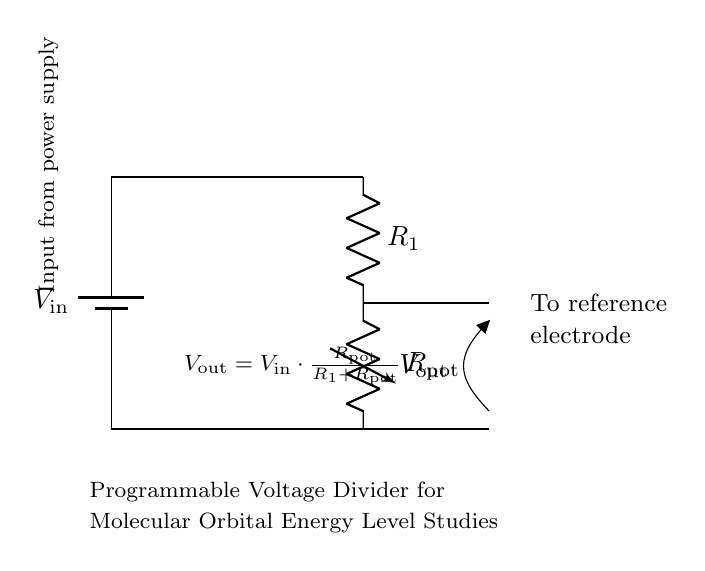What is the input voltage denoted in the diagram? The input voltage is labeled as \( V_\text{in} \) in the circuit diagram, indicating that it is the source voltage applied at the top of the circuit.
Answer: \( V_\text{in} \) What type of resistor is used to adjust the voltage output? The circuit includes a variable resistor, labeled as \( R_\text{pot} \), which allows for adjustment of the output voltage by changing its resistance.
Answer: Variable resistor What is the purpose of \( V_\text{out} \) in the circuit? \( V_\text{out} \) represents the output voltage from the voltage divider, which is supplied to a reference electrode in energy level studies.
Answer: Reference voltage Calculate the output voltage formula noted on the diagram. The formula provided shows how \( V_\text{out} \) is calculated: \( V_\text{out} = V_\text{in} \cdot \frac{R_\text{pot}}{R_1 + R_\text{pot}} \). This equation describes how the output voltage depends on the input voltage and the resistances in the circuit.
Answer: \( V_\text{out} = V_\text{in} \cdot \frac{R_\text{pot}}{R_1 + R_\text{pot}} \) Where does the output voltage connect in the circuit? The output voltage, \( V_\text{out} \), is connected to the right side of the circuit, indicating it is sent to a reference electrode, which is labeled in the diagram.
Answer: To reference electrode What is the role of the fixed resistor \( R_1 \) in this circuit? \( R_1 \) acts as a fixed part of the voltage divider, contributing to the division of input voltage along with the variable resistor, thereby helping set the output voltage.
Answer: Voltage division 